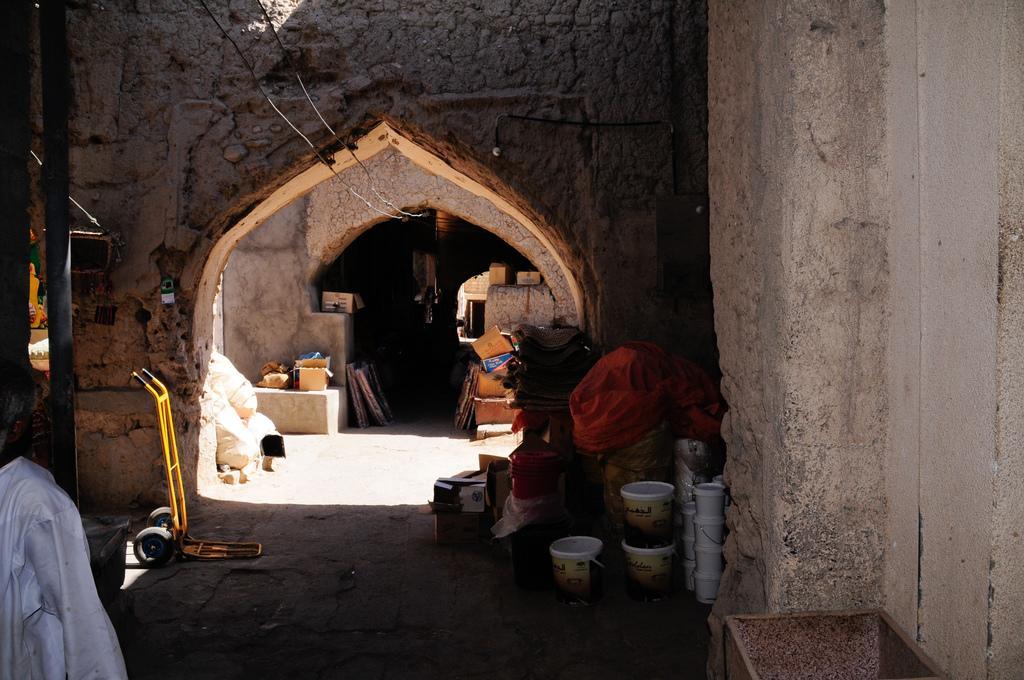How would you summarize this image in a sentence or two? In this image, at the right side we can see some buckets, there are some walls, at the left side there is a person standing. 